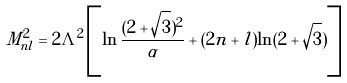<formula> <loc_0><loc_0><loc_500><loc_500>M _ { n l } ^ { 2 } = 2 \Lambda ^ { 2 } \left [ \ln \frac { ( 2 + \sqrt { 3 } ) ^ { 2 } } { \alpha } + ( 2 n + l ) \ln ( 2 + \sqrt { 3 } ) \right ]</formula> 